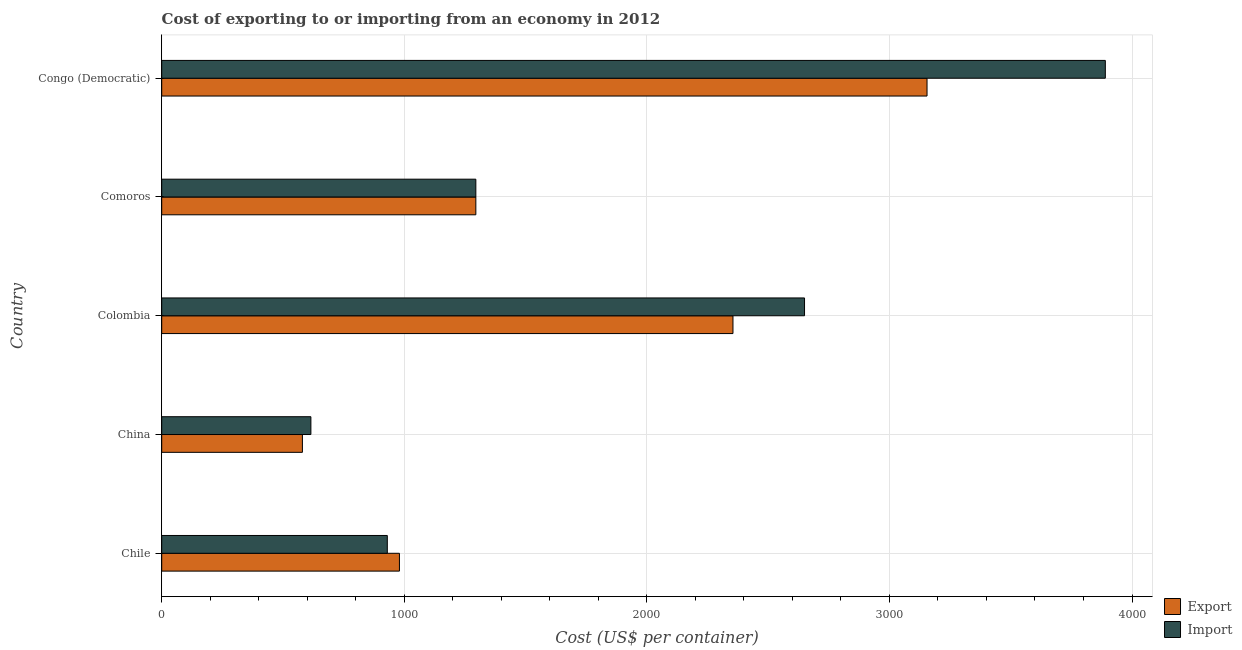How many groups of bars are there?
Your answer should be very brief. 5. Are the number of bars on each tick of the Y-axis equal?
Offer a very short reply. Yes. How many bars are there on the 4th tick from the bottom?
Make the answer very short. 2. What is the label of the 4th group of bars from the top?
Offer a very short reply. China. In how many cases, is the number of bars for a given country not equal to the number of legend labels?
Make the answer very short. 0. What is the export cost in Colombia?
Your answer should be compact. 2355. Across all countries, what is the maximum import cost?
Provide a short and direct response. 3890. Across all countries, what is the minimum import cost?
Your answer should be compact. 615. In which country was the import cost maximum?
Keep it short and to the point. Congo (Democratic). What is the total export cost in the graph?
Your answer should be compact. 8365. What is the difference between the export cost in China and that in Congo (Democratic)?
Make the answer very short. -2575. What is the difference between the import cost in China and the export cost in Comoros?
Provide a succinct answer. -680. What is the average export cost per country?
Your response must be concise. 1673. What is the difference between the export cost and import cost in Colombia?
Your answer should be very brief. -295. In how many countries, is the export cost greater than 3600 US$?
Provide a succinct answer. 0. What is the ratio of the import cost in Chile to that in China?
Your answer should be very brief. 1.51. Is the difference between the export cost in China and Congo (Democratic) greater than the difference between the import cost in China and Congo (Democratic)?
Ensure brevity in your answer.  Yes. What is the difference between the highest and the second highest import cost?
Provide a succinct answer. 1240. What is the difference between the highest and the lowest export cost?
Your answer should be compact. 2575. Is the sum of the import cost in Chile and Comoros greater than the maximum export cost across all countries?
Offer a very short reply. No. What does the 1st bar from the top in Comoros represents?
Your answer should be very brief. Import. What does the 2nd bar from the bottom in China represents?
Keep it short and to the point. Import. How many bars are there?
Your answer should be compact. 10. Are all the bars in the graph horizontal?
Offer a terse response. Yes. Does the graph contain any zero values?
Keep it short and to the point. No. How many legend labels are there?
Your answer should be compact. 2. How are the legend labels stacked?
Keep it short and to the point. Vertical. What is the title of the graph?
Your answer should be compact. Cost of exporting to or importing from an economy in 2012. Does "Foreign liabilities" appear as one of the legend labels in the graph?
Your response must be concise. No. What is the label or title of the X-axis?
Your answer should be very brief. Cost (US$ per container). What is the label or title of the Y-axis?
Keep it short and to the point. Country. What is the Cost (US$ per container) of Export in Chile?
Make the answer very short. 980. What is the Cost (US$ per container) in Import in Chile?
Your answer should be compact. 930. What is the Cost (US$ per container) in Export in China?
Make the answer very short. 580. What is the Cost (US$ per container) of Import in China?
Ensure brevity in your answer.  615. What is the Cost (US$ per container) of Export in Colombia?
Ensure brevity in your answer.  2355. What is the Cost (US$ per container) in Import in Colombia?
Give a very brief answer. 2650. What is the Cost (US$ per container) of Export in Comoros?
Your answer should be compact. 1295. What is the Cost (US$ per container) in Import in Comoros?
Ensure brevity in your answer.  1295. What is the Cost (US$ per container) of Export in Congo (Democratic)?
Offer a terse response. 3155. What is the Cost (US$ per container) in Import in Congo (Democratic)?
Your answer should be very brief. 3890. Across all countries, what is the maximum Cost (US$ per container) in Export?
Provide a succinct answer. 3155. Across all countries, what is the maximum Cost (US$ per container) in Import?
Offer a very short reply. 3890. Across all countries, what is the minimum Cost (US$ per container) of Export?
Make the answer very short. 580. Across all countries, what is the minimum Cost (US$ per container) of Import?
Provide a succinct answer. 615. What is the total Cost (US$ per container) of Export in the graph?
Provide a short and direct response. 8365. What is the total Cost (US$ per container) in Import in the graph?
Your answer should be very brief. 9380. What is the difference between the Cost (US$ per container) of Import in Chile and that in China?
Offer a terse response. 315. What is the difference between the Cost (US$ per container) of Export in Chile and that in Colombia?
Give a very brief answer. -1375. What is the difference between the Cost (US$ per container) in Import in Chile and that in Colombia?
Your response must be concise. -1720. What is the difference between the Cost (US$ per container) of Export in Chile and that in Comoros?
Give a very brief answer. -315. What is the difference between the Cost (US$ per container) in Import in Chile and that in Comoros?
Ensure brevity in your answer.  -365. What is the difference between the Cost (US$ per container) in Export in Chile and that in Congo (Democratic)?
Make the answer very short. -2175. What is the difference between the Cost (US$ per container) in Import in Chile and that in Congo (Democratic)?
Offer a very short reply. -2960. What is the difference between the Cost (US$ per container) of Export in China and that in Colombia?
Offer a terse response. -1775. What is the difference between the Cost (US$ per container) of Import in China and that in Colombia?
Offer a terse response. -2035. What is the difference between the Cost (US$ per container) in Export in China and that in Comoros?
Offer a terse response. -715. What is the difference between the Cost (US$ per container) of Import in China and that in Comoros?
Give a very brief answer. -680. What is the difference between the Cost (US$ per container) in Export in China and that in Congo (Democratic)?
Provide a succinct answer. -2575. What is the difference between the Cost (US$ per container) in Import in China and that in Congo (Democratic)?
Provide a short and direct response. -3275. What is the difference between the Cost (US$ per container) of Export in Colombia and that in Comoros?
Offer a very short reply. 1060. What is the difference between the Cost (US$ per container) in Import in Colombia and that in Comoros?
Offer a very short reply. 1355. What is the difference between the Cost (US$ per container) in Export in Colombia and that in Congo (Democratic)?
Your answer should be compact. -800. What is the difference between the Cost (US$ per container) of Import in Colombia and that in Congo (Democratic)?
Offer a very short reply. -1240. What is the difference between the Cost (US$ per container) of Export in Comoros and that in Congo (Democratic)?
Provide a succinct answer. -1860. What is the difference between the Cost (US$ per container) of Import in Comoros and that in Congo (Democratic)?
Your answer should be compact. -2595. What is the difference between the Cost (US$ per container) in Export in Chile and the Cost (US$ per container) in Import in China?
Your answer should be very brief. 365. What is the difference between the Cost (US$ per container) in Export in Chile and the Cost (US$ per container) in Import in Colombia?
Provide a short and direct response. -1670. What is the difference between the Cost (US$ per container) of Export in Chile and the Cost (US$ per container) of Import in Comoros?
Make the answer very short. -315. What is the difference between the Cost (US$ per container) in Export in Chile and the Cost (US$ per container) in Import in Congo (Democratic)?
Offer a terse response. -2910. What is the difference between the Cost (US$ per container) of Export in China and the Cost (US$ per container) of Import in Colombia?
Make the answer very short. -2070. What is the difference between the Cost (US$ per container) in Export in China and the Cost (US$ per container) in Import in Comoros?
Provide a short and direct response. -715. What is the difference between the Cost (US$ per container) in Export in China and the Cost (US$ per container) in Import in Congo (Democratic)?
Offer a very short reply. -3310. What is the difference between the Cost (US$ per container) of Export in Colombia and the Cost (US$ per container) of Import in Comoros?
Ensure brevity in your answer.  1060. What is the difference between the Cost (US$ per container) of Export in Colombia and the Cost (US$ per container) of Import in Congo (Democratic)?
Make the answer very short. -1535. What is the difference between the Cost (US$ per container) in Export in Comoros and the Cost (US$ per container) in Import in Congo (Democratic)?
Keep it short and to the point. -2595. What is the average Cost (US$ per container) in Export per country?
Offer a very short reply. 1673. What is the average Cost (US$ per container) in Import per country?
Provide a succinct answer. 1876. What is the difference between the Cost (US$ per container) in Export and Cost (US$ per container) in Import in Chile?
Your answer should be compact. 50. What is the difference between the Cost (US$ per container) in Export and Cost (US$ per container) in Import in China?
Offer a terse response. -35. What is the difference between the Cost (US$ per container) in Export and Cost (US$ per container) in Import in Colombia?
Provide a short and direct response. -295. What is the difference between the Cost (US$ per container) in Export and Cost (US$ per container) in Import in Congo (Democratic)?
Your answer should be very brief. -735. What is the ratio of the Cost (US$ per container) of Export in Chile to that in China?
Your answer should be compact. 1.69. What is the ratio of the Cost (US$ per container) in Import in Chile to that in China?
Keep it short and to the point. 1.51. What is the ratio of the Cost (US$ per container) in Export in Chile to that in Colombia?
Keep it short and to the point. 0.42. What is the ratio of the Cost (US$ per container) in Import in Chile to that in Colombia?
Make the answer very short. 0.35. What is the ratio of the Cost (US$ per container) of Export in Chile to that in Comoros?
Make the answer very short. 0.76. What is the ratio of the Cost (US$ per container) in Import in Chile to that in Comoros?
Provide a succinct answer. 0.72. What is the ratio of the Cost (US$ per container) in Export in Chile to that in Congo (Democratic)?
Offer a very short reply. 0.31. What is the ratio of the Cost (US$ per container) of Import in Chile to that in Congo (Democratic)?
Your answer should be very brief. 0.24. What is the ratio of the Cost (US$ per container) of Export in China to that in Colombia?
Ensure brevity in your answer.  0.25. What is the ratio of the Cost (US$ per container) in Import in China to that in Colombia?
Keep it short and to the point. 0.23. What is the ratio of the Cost (US$ per container) in Export in China to that in Comoros?
Give a very brief answer. 0.45. What is the ratio of the Cost (US$ per container) of Import in China to that in Comoros?
Keep it short and to the point. 0.47. What is the ratio of the Cost (US$ per container) in Export in China to that in Congo (Democratic)?
Ensure brevity in your answer.  0.18. What is the ratio of the Cost (US$ per container) of Import in China to that in Congo (Democratic)?
Your answer should be very brief. 0.16. What is the ratio of the Cost (US$ per container) of Export in Colombia to that in Comoros?
Make the answer very short. 1.82. What is the ratio of the Cost (US$ per container) in Import in Colombia to that in Comoros?
Provide a short and direct response. 2.05. What is the ratio of the Cost (US$ per container) in Export in Colombia to that in Congo (Democratic)?
Give a very brief answer. 0.75. What is the ratio of the Cost (US$ per container) in Import in Colombia to that in Congo (Democratic)?
Your answer should be compact. 0.68. What is the ratio of the Cost (US$ per container) in Export in Comoros to that in Congo (Democratic)?
Your response must be concise. 0.41. What is the ratio of the Cost (US$ per container) in Import in Comoros to that in Congo (Democratic)?
Offer a terse response. 0.33. What is the difference between the highest and the second highest Cost (US$ per container) in Export?
Your answer should be very brief. 800. What is the difference between the highest and the second highest Cost (US$ per container) in Import?
Ensure brevity in your answer.  1240. What is the difference between the highest and the lowest Cost (US$ per container) of Export?
Ensure brevity in your answer.  2575. What is the difference between the highest and the lowest Cost (US$ per container) in Import?
Keep it short and to the point. 3275. 